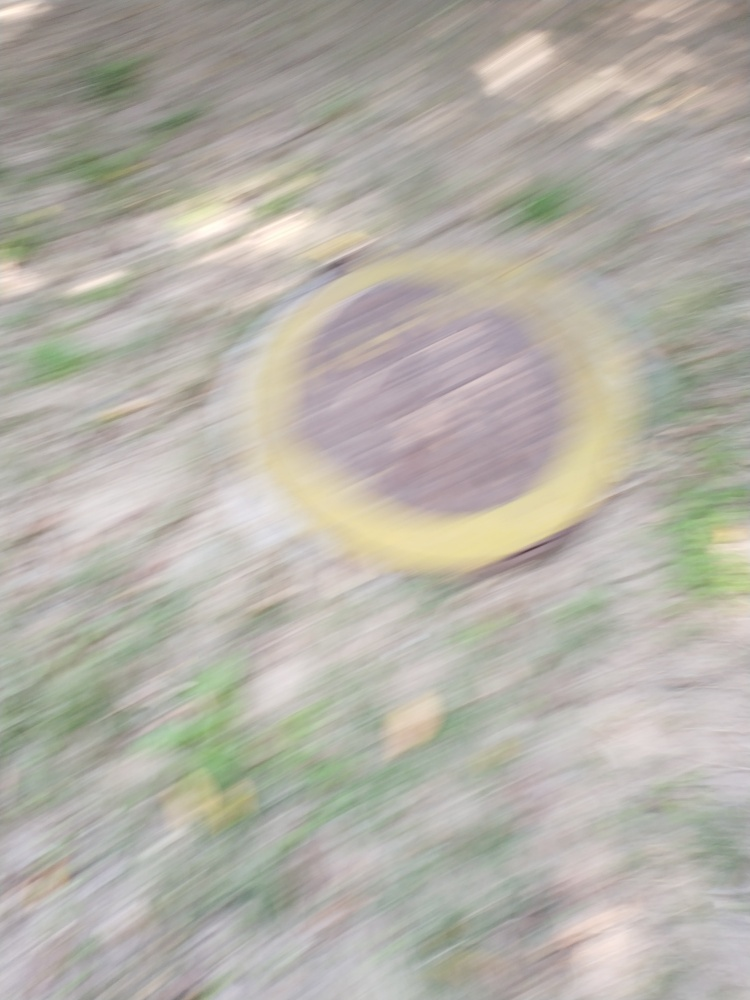Why is it difficult to see anything clearly in this image?
A. The image is well-focused.
B. The lighting conditions are poor.
C. The image is out of focus.
D. The lens used for capturing the image was low quality.
Answer with the option's letter from the given choices directly. The clarity issues within the image appear to be most closely associated with Option C: The image is out of focus. This can typically happen when the camera moves during the exposure process, especially if the shutter speed isn't fast enough to freeze motion. While it's less likely that bad lighting or lens quality alone would cause this degree of blurring, they might contribute to the problem in combination with other factors. That said, the predominant factor seems to be the focus, not the lighting or the lens quality. Hence, the revised answer to the question is 'Option C: The image is out of focus.' 